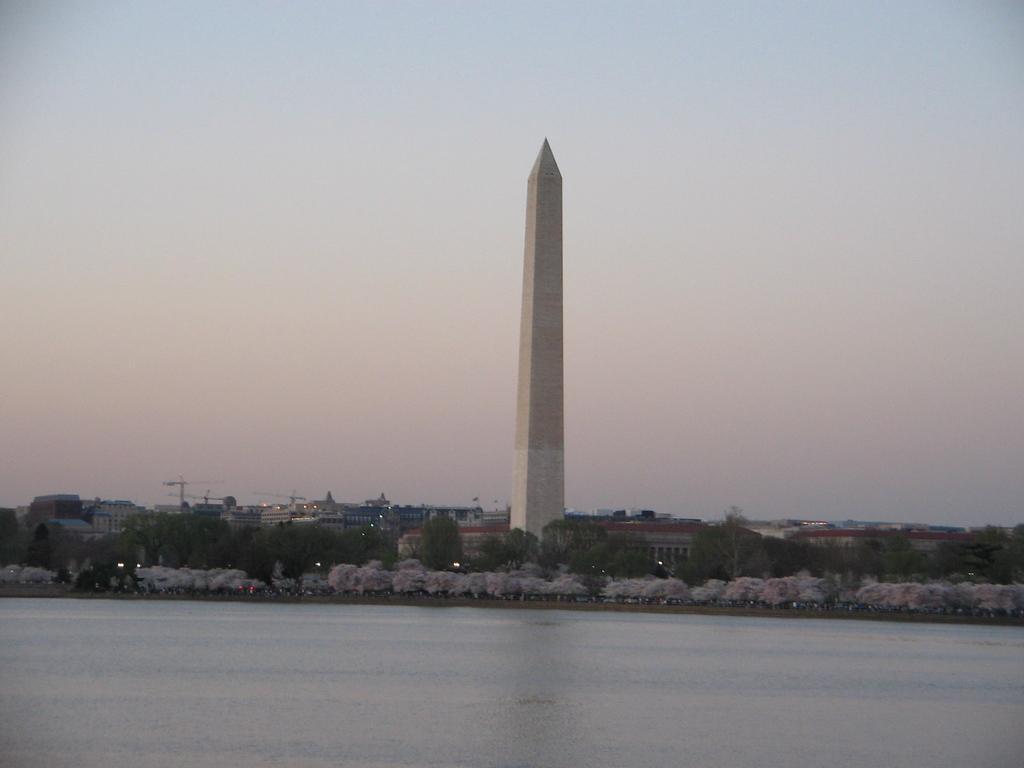Describe this image in one or two sentences. In this image I can see the water, few trees and a tower. In the background I can see few buildings, few cranes and the sky. 